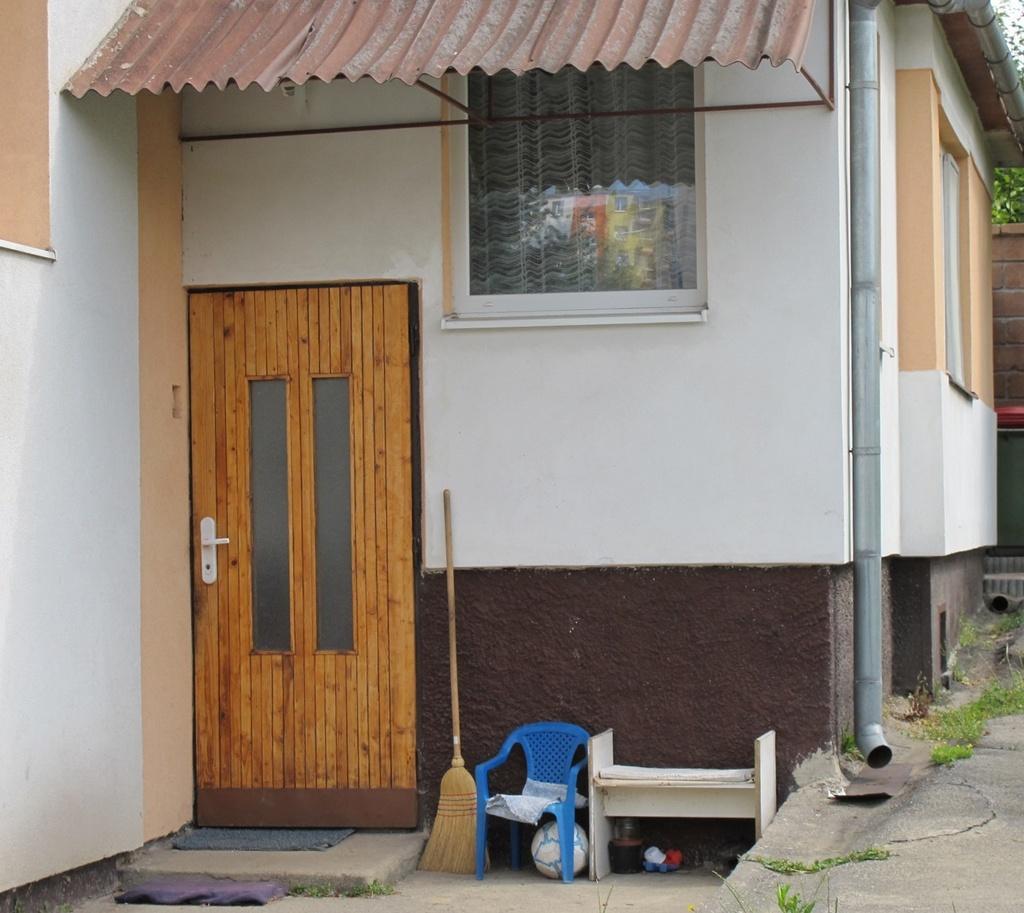Could you give a brief overview of what you see in this image? In this image there is a broomstick, ball and a rack are near the wall of house having a door and window. A pipe is attached to the wall. There is some grass on the land. Right side there is a wall. Behind there is a tree. 